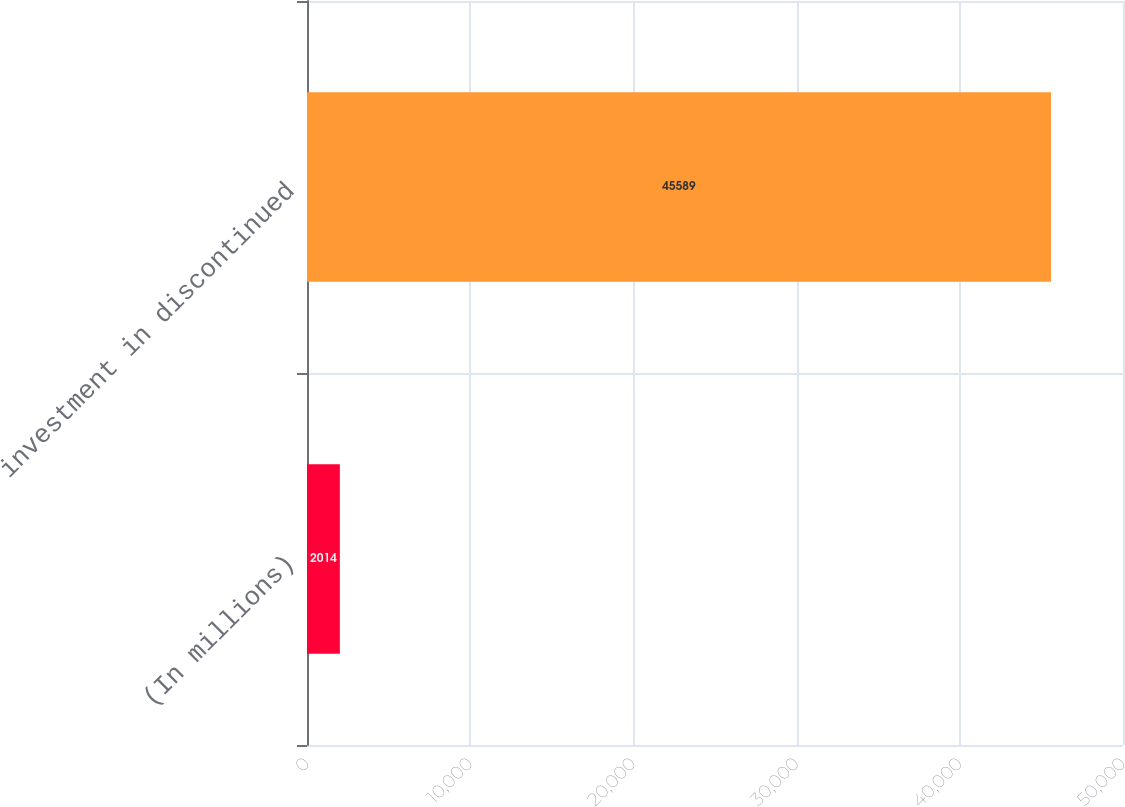Convert chart to OTSL. <chart><loc_0><loc_0><loc_500><loc_500><bar_chart><fcel>(In millions)<fcel>investment in discontinued<nl><fcel>2014<fcel>45589<nl></chart> 